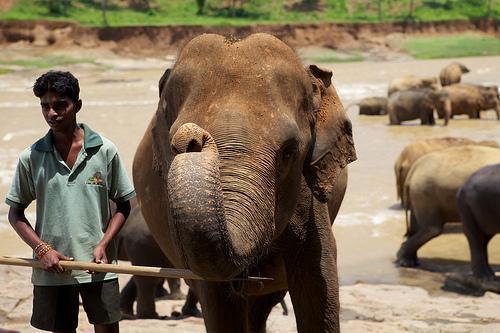How many men?
Give a very brief answer. 1. 